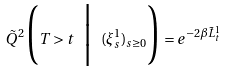<formula> <loc_0><loc_0><loc_500><loc_500>\tilde { Q } ^ { 2 } \Big ( T > t \ \Big | \ ( \xi ^ { 1 } _ { s } ) _ { s \geq 0 } \Big ) = e ^ { - 2 \beta \tilde { L } ^ { 1 } _ { t } }</formula> 